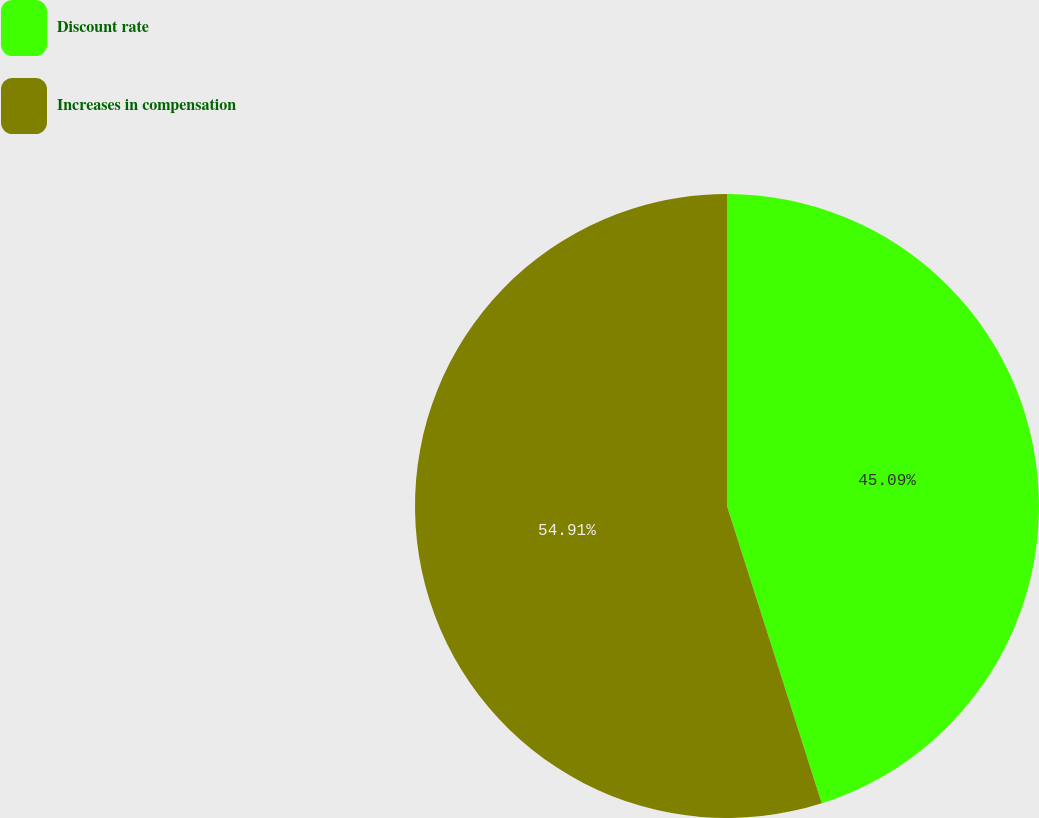<chart> <loc_0><loc_0><loc_500><loc_500><pie_chart><fcel>Discount rate<fcel>Increases in compensation<nl><fcel>45.09%<fcel>54.91%<nl></chart> 